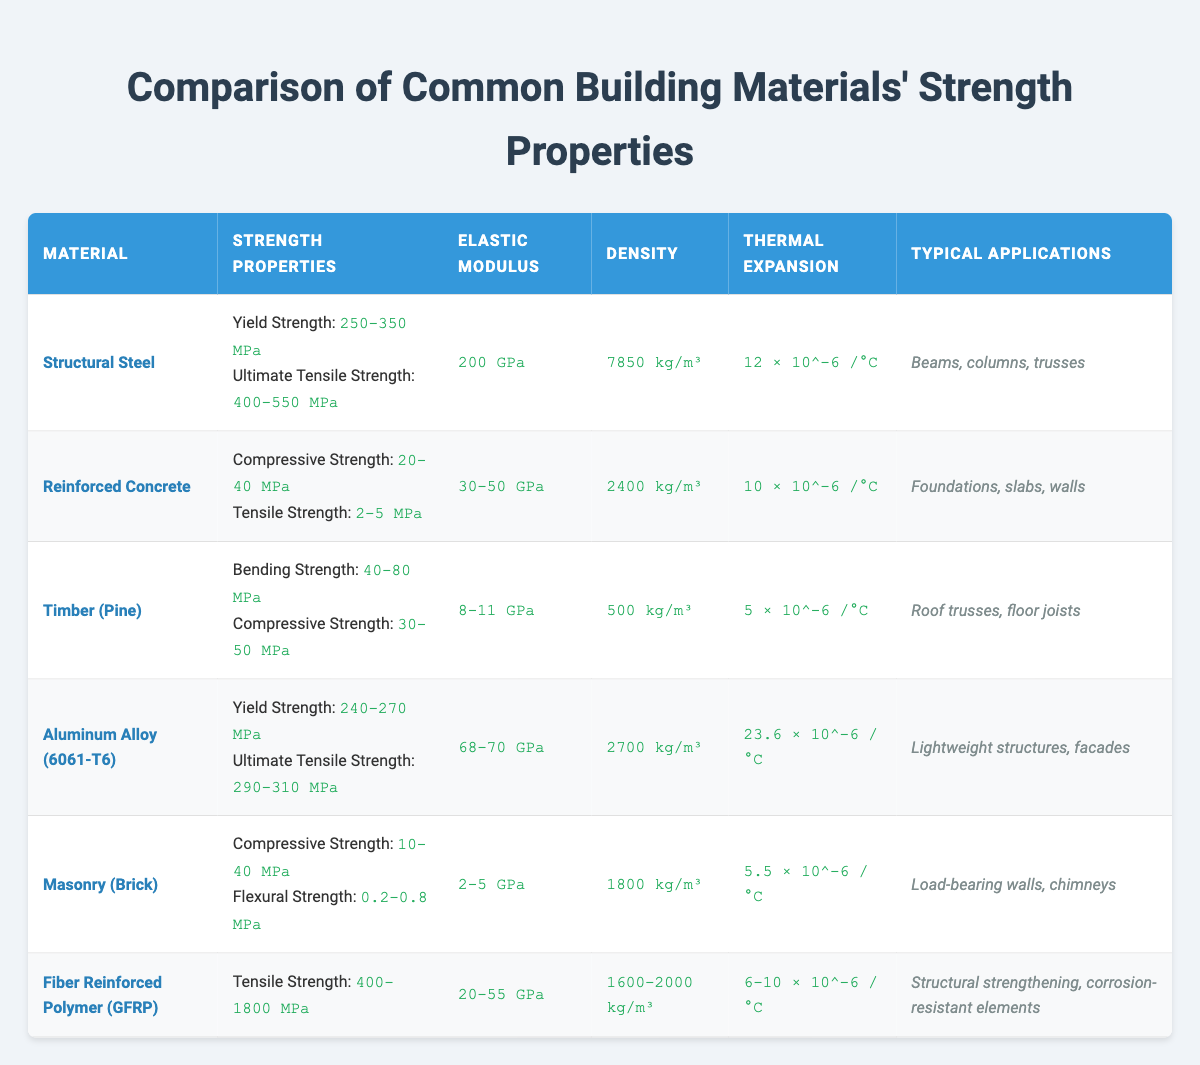What is the yield strength range for Structural Steel? From the table, the yield strength for Structural Steel is listed as 250-350 MPa.
Answer: 250-350 MPa What is the typical application for Aluminum Alloy (6061-T6)? The table indicates that Aluminum Alloy (6061-T6) is typically used in lightweight structures and facades.
Answer: Lightweight structures, facades Which material has the highest tensile strength? By comparing the tensile strength values in the table, Fiber Reinforced Polymer (GFRP) has a tensile strength range of 400-1800 MPa, which is higher than the other materials listed.
Answer: Fiber Reinforced Polymer (GFRP) What is the density of Reinforced Concrete? The density of Reinforced Concrete is stated in the table as 2400 kg/m³.
Answer: 2400 kg/m³ Is the thermal expansion of Timber (Pine) greater than that of Masonry (Brick)? The thermal expansion for Timber (Pine) is 5 × 10^-6 /°C and for Masonry (Brick) it is 5.5 × 10^-6 /°C. Since 5.5 is greater than 5, Timber (Pine) has less thermal expansion than Masonry (Brick).
Answer: No What is the average elastic modulus of all the materials listed in the table? The elastic moduli provided are: 200 GPa (Steel), 30-50 GPa (Concrete: average = 40 GPa), 8-11 GPa (Timber: average = 9.5 GPa), 68-70 GPa (Aluminum: average = 69 GPa), 2-5 GPa (Masonry: average = 3.5 GPa), 20-55 GPa (GFRP: average = 37.5 GPa). Adding these averages gives 200 + 40 + 9.5 + 69 + 3.5 + 37.5 = 359.5 GPa. Dividing this by 6 (number of materials) yields an average of approximately 59.92 GPa.
Answer: Approximately 59.92 GPa Which material has the lowest compressive strength range? The compressive strength of the materials are: Structural Steel (not provided), Reinforced Concrete (20-40 MPa), Timber (30-50 MPa), Masonry (10-40 MPa), and GFRP (not provided). Since Masonry has the lowest compressive strength range (10-40 MPa), it is identified as the lowest.
Answer: Masonry (Brick) What is the ratio of the ultimate tensile strength of Structural Steel to the yield strength of Aluminum Alloy (6061-T6)? The ultimate tensile strength of Structural Steel is 400-550 MPa, and the yield strength of Aluminum Alloy (6061-T6) is 240-270 MPa. To find the ratio, we can take the average yield strength of 255 MPa from aluminum and assume an average ultimate tensile strength of 475 MPa from steel, resulting in 475/255, which equals approximately 1.86.
Answer: Approximately 1.86 Does Fiber Reinforced Polymer (GFRP) have any typical applications listed? According to the table, Fiber Reinforced Polymer (GFRP) is used for structural strengthening and corrosion-resistant elements, so the answer is yes.
Answer: Yes 